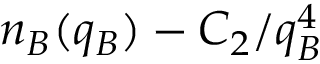Convert formula to latex. <formula><loc_0><loc_0><loc_500><loc_500>n _ { B } ( q _ { B } ) - C _ { 2 } / q _ { B } ^ { 4 }</formula> 